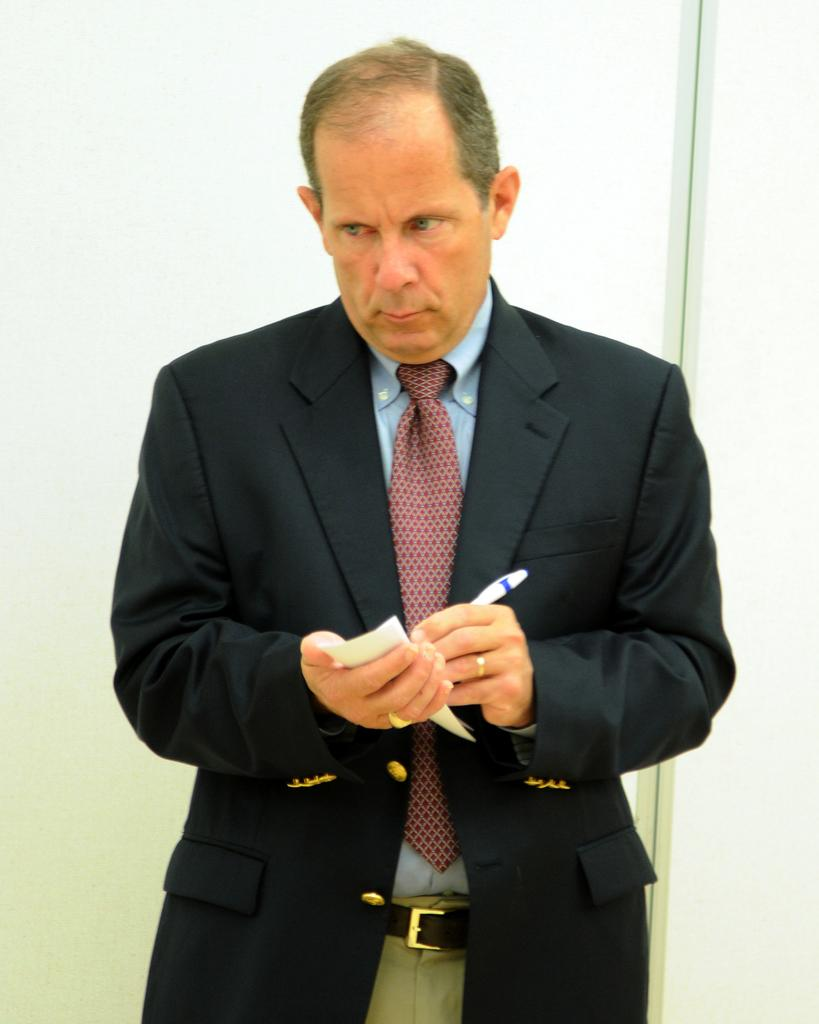What is the main subject of the image? There is a person in the center of the image. What is the person holding in the image? The person is holding a pen and a paper. What can be seen in the background of the image? There is a wall in the background of the image. What type of harbor can be seen in the image? There is no harbor present in the image; it features a person holding a pen and a paper with a wall in the background. 